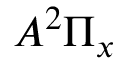Convert formula to latex. <formula><loc_0><loc_0><loc_500><loc_500>A ^ { 2 } \Pi _ { x }</formula> 